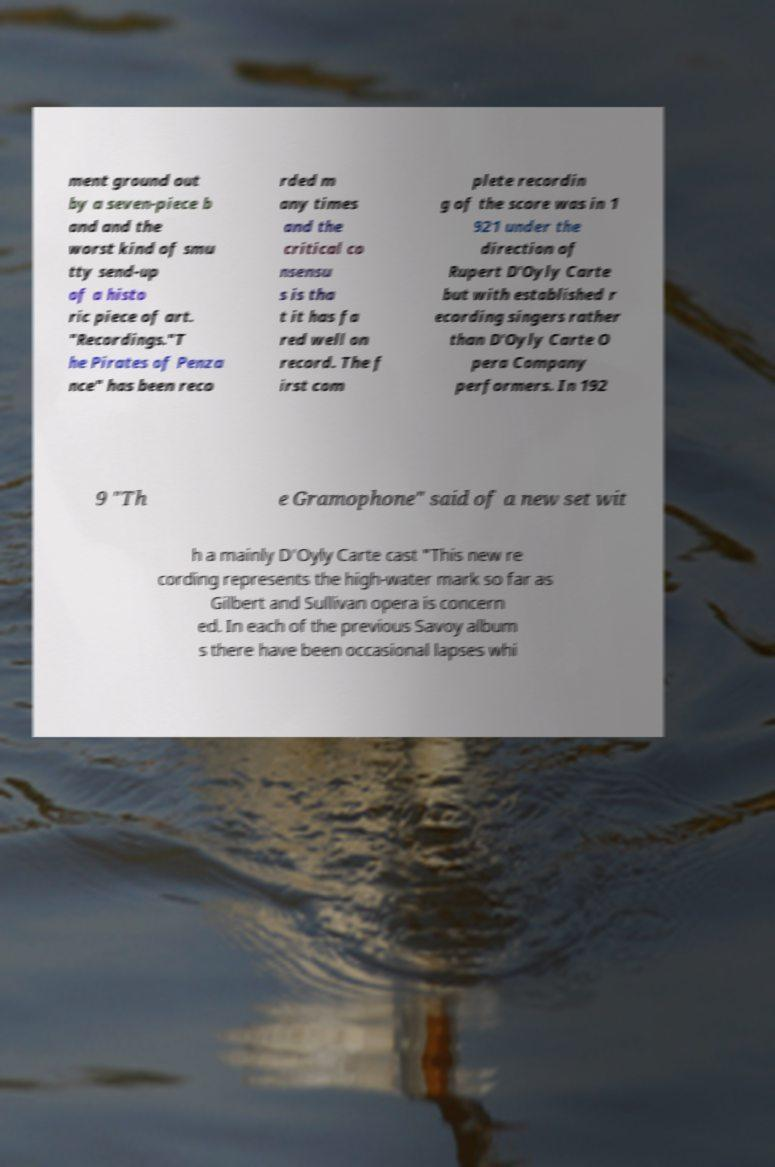Could you assist in decoding the text presented in this image and type it out clearly? ment ground out by a seven-piece b and and the worst kind of smu tty send-up of a histo ric piece of art. "Recordings."T he Pirates of Penza nce" has been reco rded m any times and the critical co nsensu s is tha t it has fa red well on record. The f irst com plete recordin g of the score was in 1 921 under the direction of Rupert D'Oyly Carte but with established r ecording singers rather than D'Oyly Carte O pera Company performers. In 192 9 "Th e Gramophone" said of a new set wit h a mainly D'Oyly Carte cast "This new re cording represents the high-water mark so far as Gilbert and Sullivan opera is concern ed. In each of the previous Savoy album s there have been occasional lapses whi 